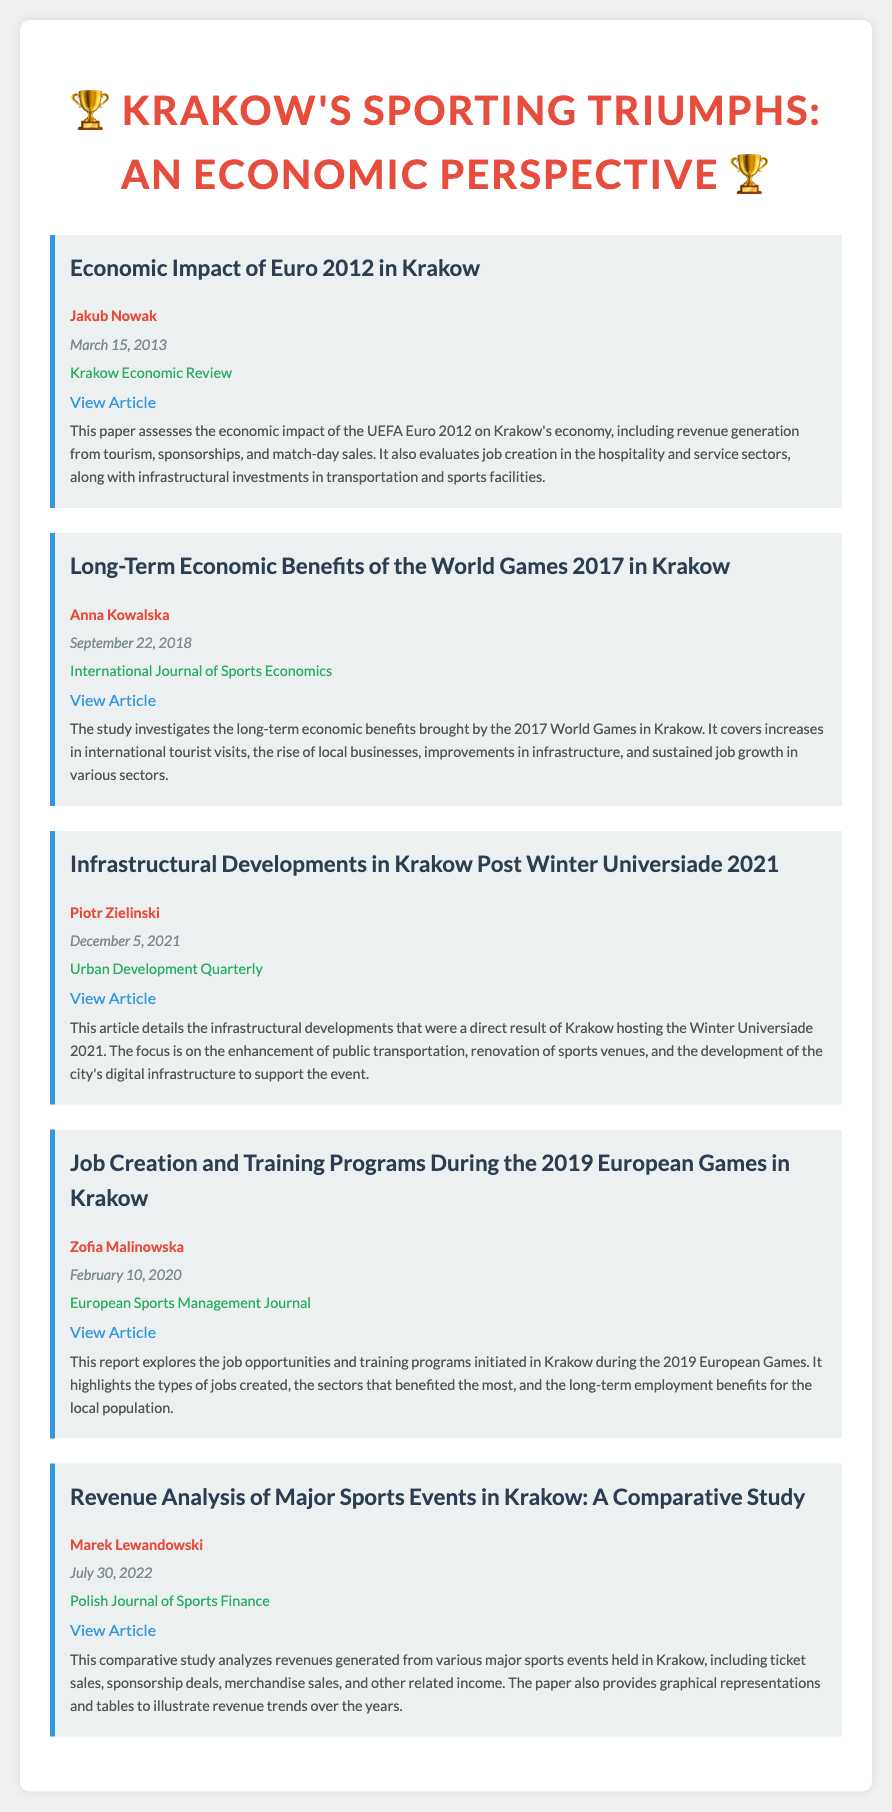What is the title of the first entry? The title of the first entry is about the economic impact of a specific sports event held in Krakow.
Answer: Economic Impact of Euro 2012 in Krakow Who authored the paper on long-term economic benefits? This question focuses on identifying the author of a specific study regarding another major sporting event.
Answer: Anna Kowalska When was the report on job creation and training programs published? The publication date provides insight into when this specific analysis was made available.
Answer: February 10, 2020 Which event is associated with infrastructural developments in the document? This question seeks to clarify which specific sports event led to infrastructural growth in Krakow.
Answer: Winter Universiade 2021 How many authors are listed for the articles in this bibliography? This question looks at the total number of individuals contributing to the articles referenced in the document.
Answer: Four What is the publisher of the revenue analysis study? By identifying the publisher, this question emphasizes the source of the particular document mentioned.
Answer: Polish Journal of Sports Finance Which article discusses job opportunities during a sports event? This question addresses one specific aspect of the document focusing on employment opportunities related to a sports event.
Answer: Job Creation and Training Programs During the 2019 European Games in Krakow What is the publication date of the article on Euro 2012? This question focuses on the specific timing of the publication regarding the economic impacts of Euro 2012.
Answer: March 15, 2013 What color is used for the entry headers? This question points towards the aesthetic choices made in the document's design for clarity and visual appeal.
Answer: Blue 